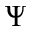Convert formula to latex. <formula><loc_0><loc_0><loc_500><loc_500>\Psi</formula> 